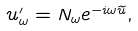Convert formula to latex. <formula><loc_0><loc_0><loc_500><loc_500>u _ { \omega } ^ { \prime } = N _ { \omega } e ^ { - i \omega \widetilde { u } } ,</formula> 